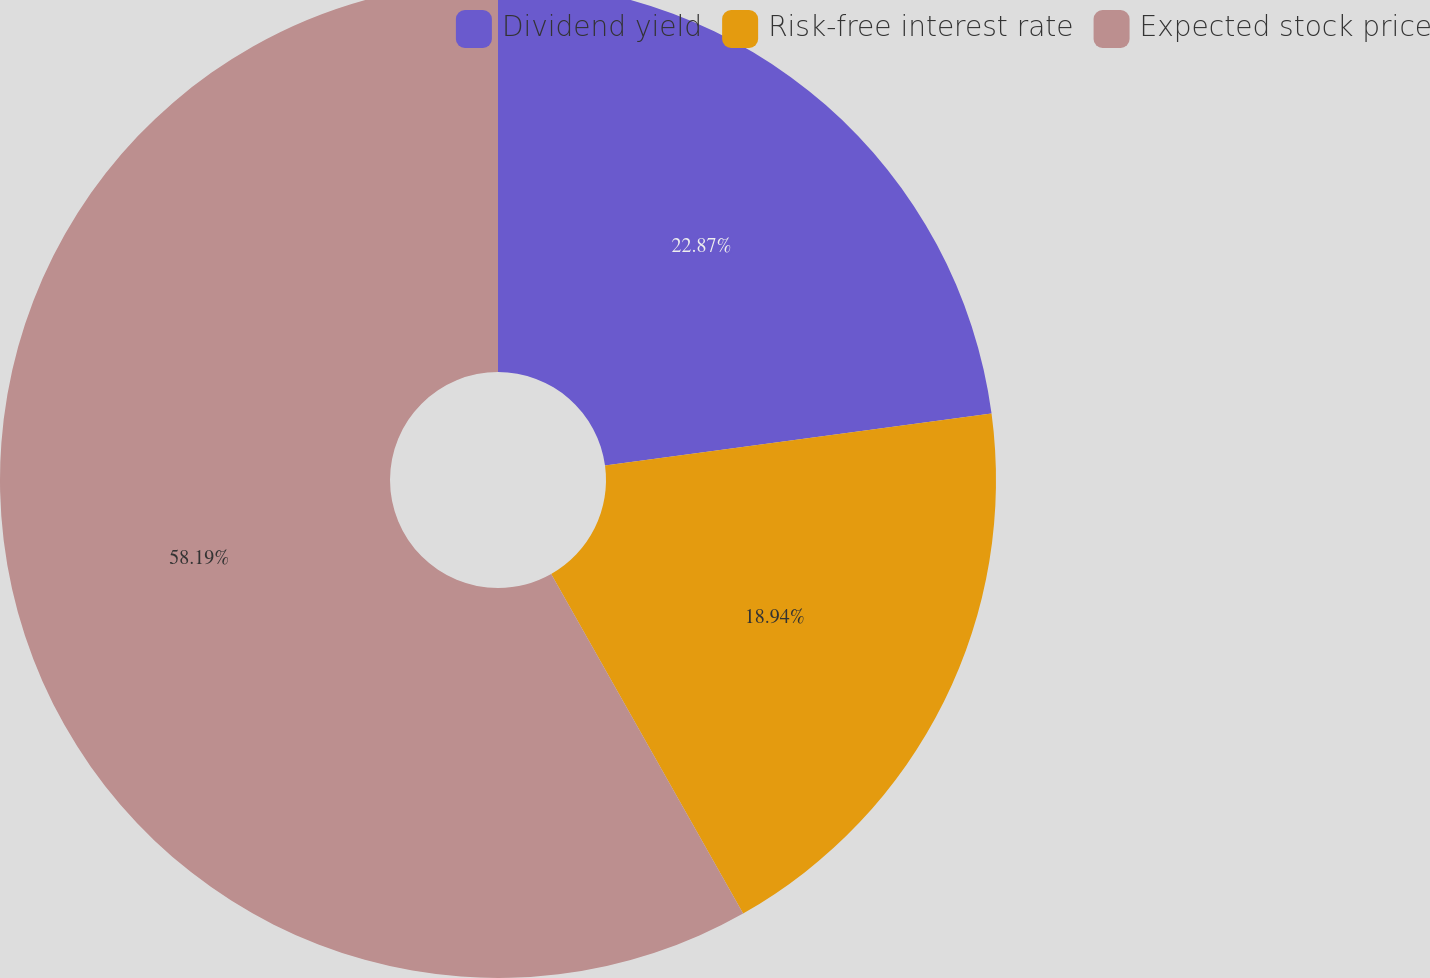Convert chart to OTSL. <chart><loc_0><loc_0><loc_500><loc_500><pie_chart><fcel>Dividend yield<fcel>Risk-free interest rate<fcel>Expected stock price<nl><fcel>22.87%<fcel>18.94%<fcel>58.19%<nl></chart> 